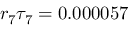<formula> <loc_0><loc_0><loc_500><loc_500>r _ { 7 } \tau _ { 7 } = 0 . 0 0 0 0 5 7</formula> 